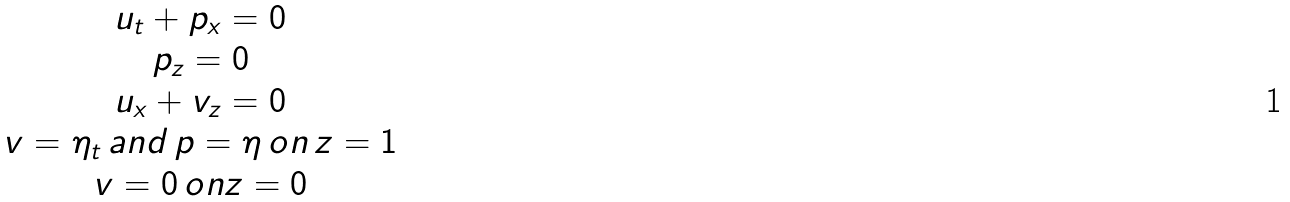Convert formula to latex. <formula><loc_0><loc_0><loc_500><loc_500>\begin{array} { c } u _ { t } + p _ { x } = 0 \\ p _ { z } = 0 \\ u _ { x } + v _ { z } = 0 \\ v = \eta _ { t } \, a n d \, p = \eta \, o n \, z = 1 \\ v = 0 \, o n z = 0 \end{array}</formula> 